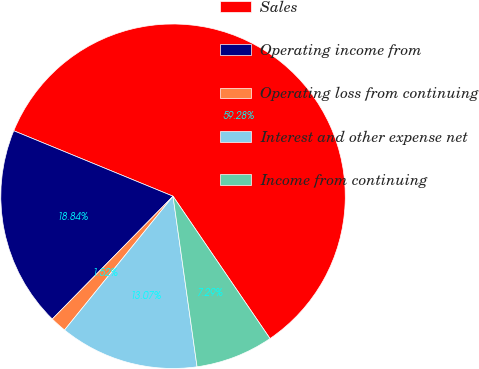Convert chart. <chart><loc_0><loc_0><loc_500><loc_500><pie_chart><fcel>Sales<fcel>Operating income from<fcel>Operating loss from continuing<fcel>Interest and other expense net<fcel>Income from continuing<nl><fcel>59.27%<fcel>18.84%<fcel>1.52%<fcel>13.07%<fcel>7.29%<nl></chart> 